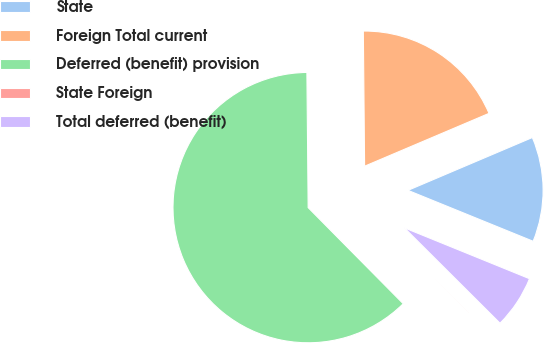Convert chart. <chart><loc_0><loc_0><loc_500><loc_500><pie_chart><fcel>State<fcel>Foreign Total current<fcel>Deferred (benefit) provision<fcel>State Foreign<fcel>Total deferred (benefit)<nl><fcel>12.54%<fcel>18.76%<fcel>62.27%<fcel>0.11%<fcel>6.33%<nl></chart> 